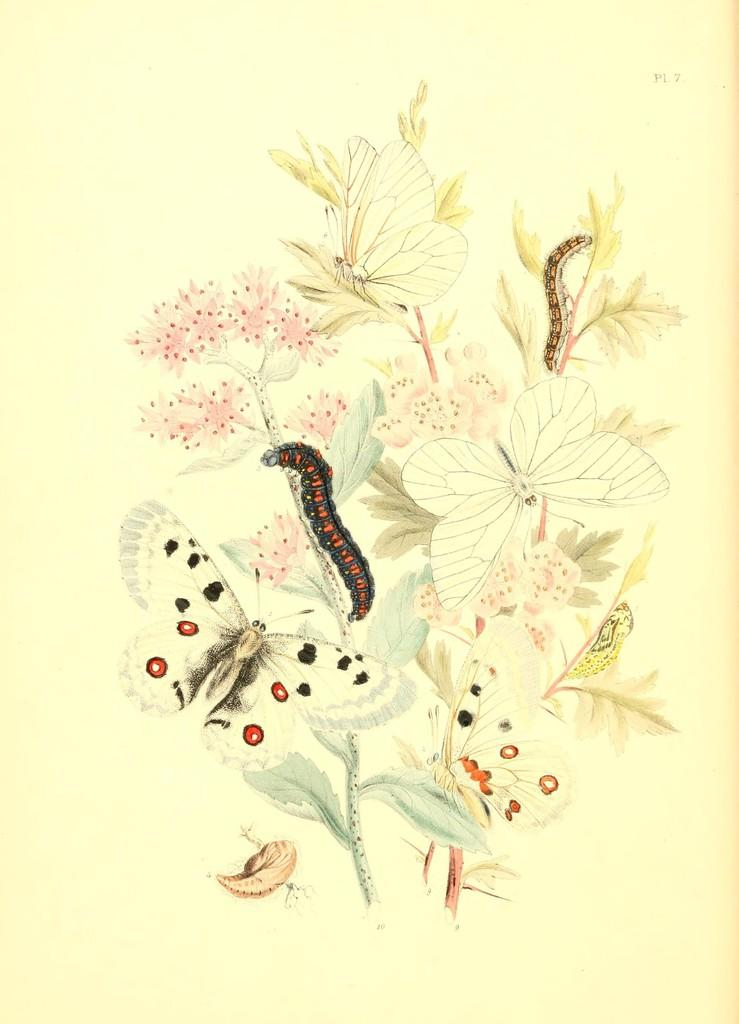What is the main subject of the image? There is an art piece in the image. What stage of development is the heart in the image? There is no heart present in the image, as the main subject is an art piece. 